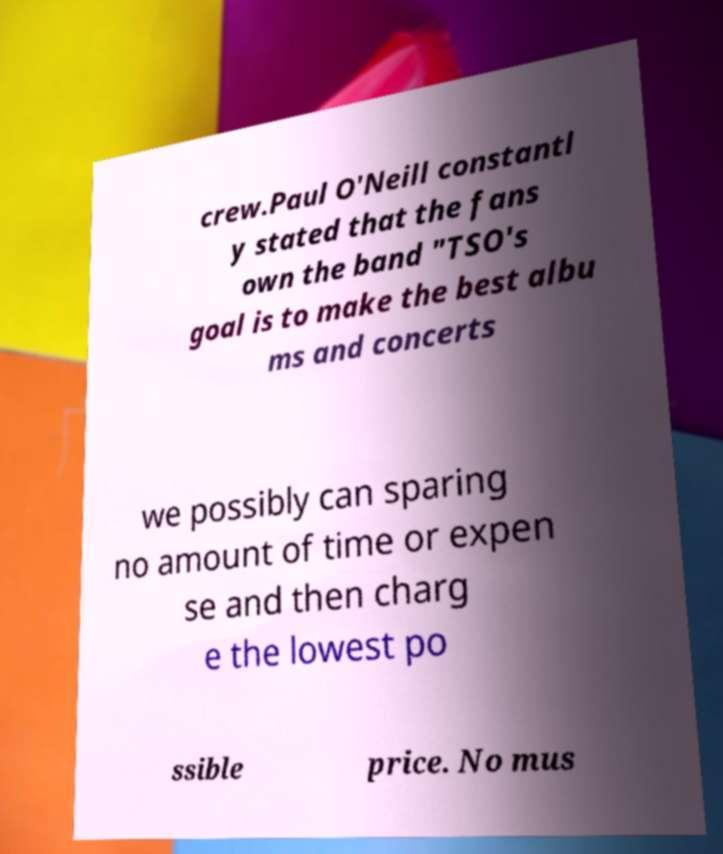Could you assist in decoding the text presented in this image and type it out clearly? crew.Paul O'Neill constantl y stated that the fans own the band "TSO's goal is to make the best albu ms and concerts we possibly can sparing no amount of time or expen se and then charg e the lowest po ssible price. No mus 